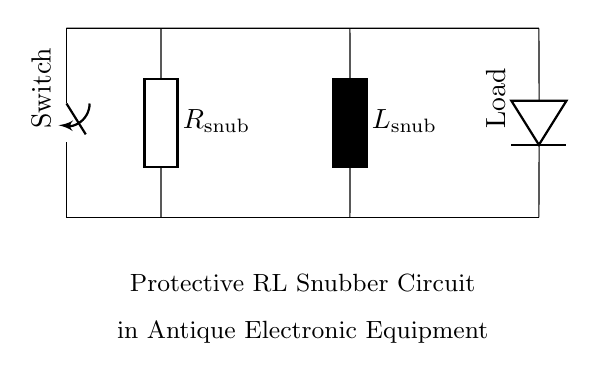What is the type of load in the circuit? The load is represented by the diode symbol labeled "Load," indicating that it's likely a resistive or reactive load.
Answer: Load What are the component values of the circuit? The circuit diagram does not specify numerical values for the resistor and inductor, indicating that either can be selected based on design requirements.
Answer: Not specified What is the purpose of the resistor in this circuit? The resistor, known as the snubber resistor, aids in absorbing voltage spikes and protecting sensitive components from transients caused by the inductor.
Answer: Absorbing voltage spikes How does the inductor affect the circuit response? The inductor introduces a time delay and stores energy in the magnetic field, contributing to the circuit's overall damping effect and reducing oscillations.
Answer: Damping effect What is the relationship between the resistor and inductor in a snubber circuit? In a snubber circuit, the resistor and inductor work together to clamp voltage spikes, where the resistor dissipates energy while the inductor delays current changes.
Answer: Voltage clamping 